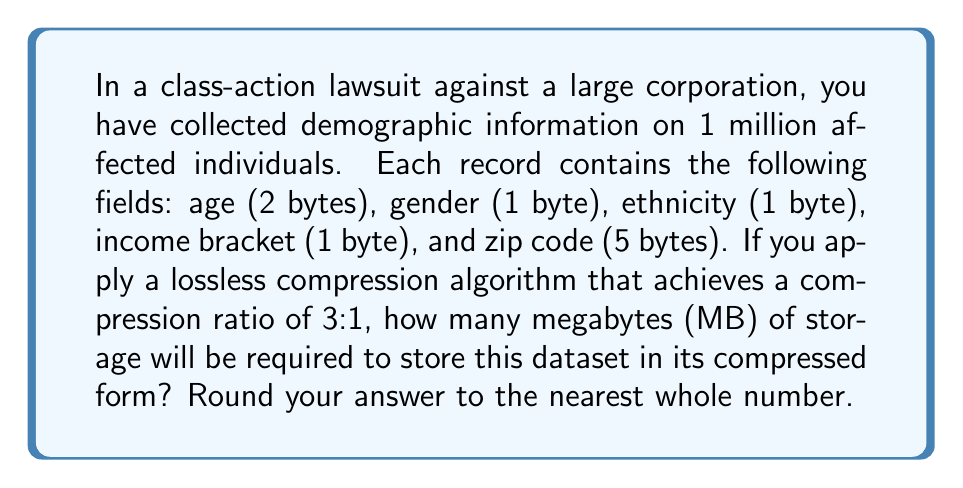Can you answer this question? Let's approach this step-by-step:

1. Calculate the size of each uncompressed record:
   $$ \text{Record size} = 2 + 1 + 1 + 1 + 5 = 10 \text{ bytes} $$

2. Calculate the total size of the uncompressed dataset:
   $$ \text{Uncompressed size} = 10 \text{ bytes} \times 1,000,000 \text{ records} = 10,000,000 \text{ bytes} $$

3. Convert bytes to megabytes:
   $$ \text{Uncompressed size in MB} = \frac{10,000,000 \text{ bytes}}{1,024,000 \text{ bytes/MB}} \approx 9.54 \text{ MB} $$

4. Apply the compression ratio of 3:1:
   $$ \text{Compressed size} = \frac{\text{Uncompressed size}}{3} = \frac{9.54 \text{ MB}}{3} \approx 3.18 \text{ MB} $$

5. Round to the nearest whole number:
   $$ \text{Rounded compressed size} = 3 \text{ MB} $$
Answer: 3 MB 